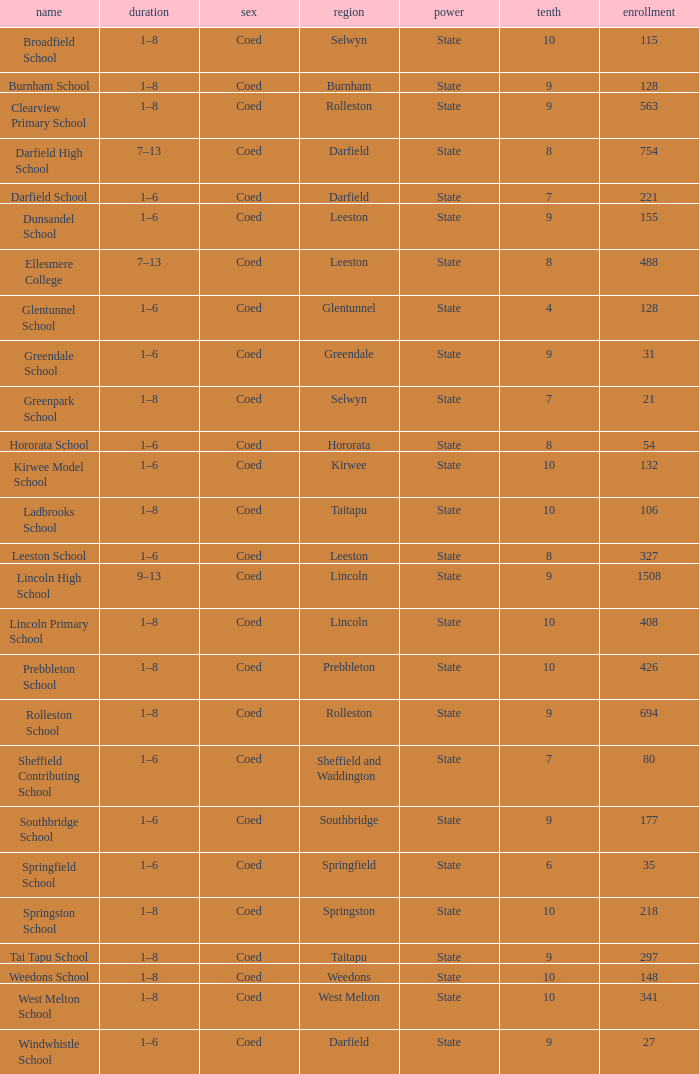Parse the table in full. {'header': ['name', 'duration', 'sex', 'region', 'power', 'tenth', 'enrollment'], 'rows': [['Broadfield School', '1–8', 'Coed', 'Selwyn', 'State', '10', '115'], ['Burnham School', '1–8', 'Coed', 'Burnham', 'State', '9', '128'], ['Clearview Primary School', '1–8', 'Coed', 'Rolleston', 'State', '9', '563'], ['Darfield High School', '7–13', 'Coed', 'Darfield', 'State', '8', '754'], ['Darfield School', '1–6', 'Coed', 'Darfield', 'State', '7', '221'], ['Dunsandel School', '1–6', 'Coed', 'Leeston', 'State', '9', '155'], ['Ellesmere College', '7–13', 'Coed', 'Leeston', 'State', '8', '488'], ['Glentunnel School', '1–6', 'Coed', 'Glentunnel', 'State', '4', '128'], ['Greendale School', '1–6', 'Coed', 'Greendale', 'State', '9', '31'], ['Greenpark School', '1–8', 'Coed', 'Selwyn', 'State', '7', '21'], ['Hororata School', '1–6', 'Coed', 'Hororata', 'State', '8', '54'], ['Kirwee Model School', '1–6', 'Coed', 'Kirwee', 'State', '10', '132'], ['Ladbrooks School', '1–8', 'Coed', 'Taitapu', 'State', '10', '106'], ['Leeston School', '1–6', 'Coed', 'Leeston', 'State', '8', '327'], ['Lincoln High School', '9–13', 'Coed', 'Lincoln', 'State', '9', '1508'], ['Lincoln Primary School', '1–8', 'Coed', 'Lincoln', 'State', '10', '408'], ['Prebbleton School', '1–8', 'Coed', 'Prebbleton', 'State', '10', '426'], ['Rolleston School', '1–8', 'Coed', 'Rolleston', 'State', '9', '694'], ['Sheffield Contributing School', '1–6', 'Coed', 'Sheffield and Waddington', 'State', '7', '80'], ['Southbridge School', '1–6', 'Coed', 'Southbridge', 'State', '9', '177'], ['Springfield School', '1–6', 'Coed', 'Springfield', 'State', '6', '35'], ['Springston School', '1–8', 'Coed', 'Springston', 'State', '10', '218'], ['Tai Tapu School', '1–8', 'Coed', 'Taitapu', 'State', '9', '297'], ['Weedons School', '1–8', 'Coed', 'Weedons', 'State', '10', '148'], ['West Melton School', '1–8', 'Coed', 'West Melton', 'State', '10', '341'], ['Windwhistle School', '1–6', 'Coed', 'Darfield', 'State', '9', '27']]} What is the total of the roll with a Decile of 8, and an Area of hororata? 54.0. 